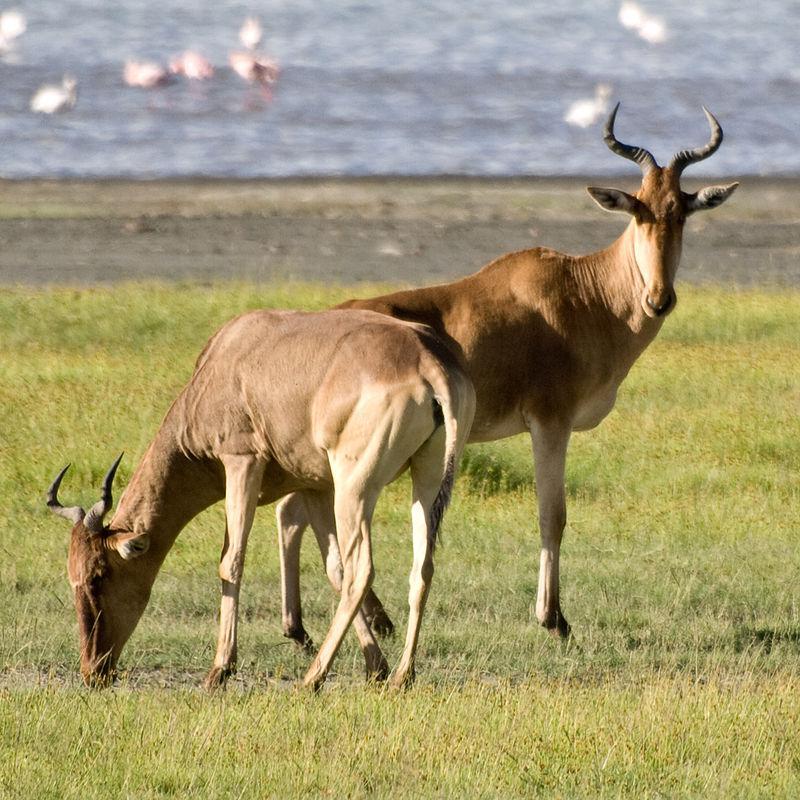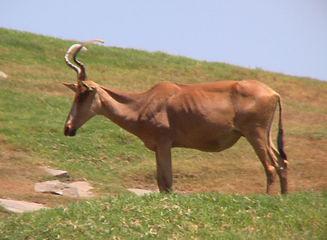The first image is the image on the left, the second image is the image on the right. Considering the images on both sides, is "An image shows exactly five hooved animals with horns." valid? Answer yes or no. No. The first image is the image on the left, the second image is the image on the right. For the images shown, is this caption "there is exactly one animal in the image on the left" true? Answer yes or no. No. 